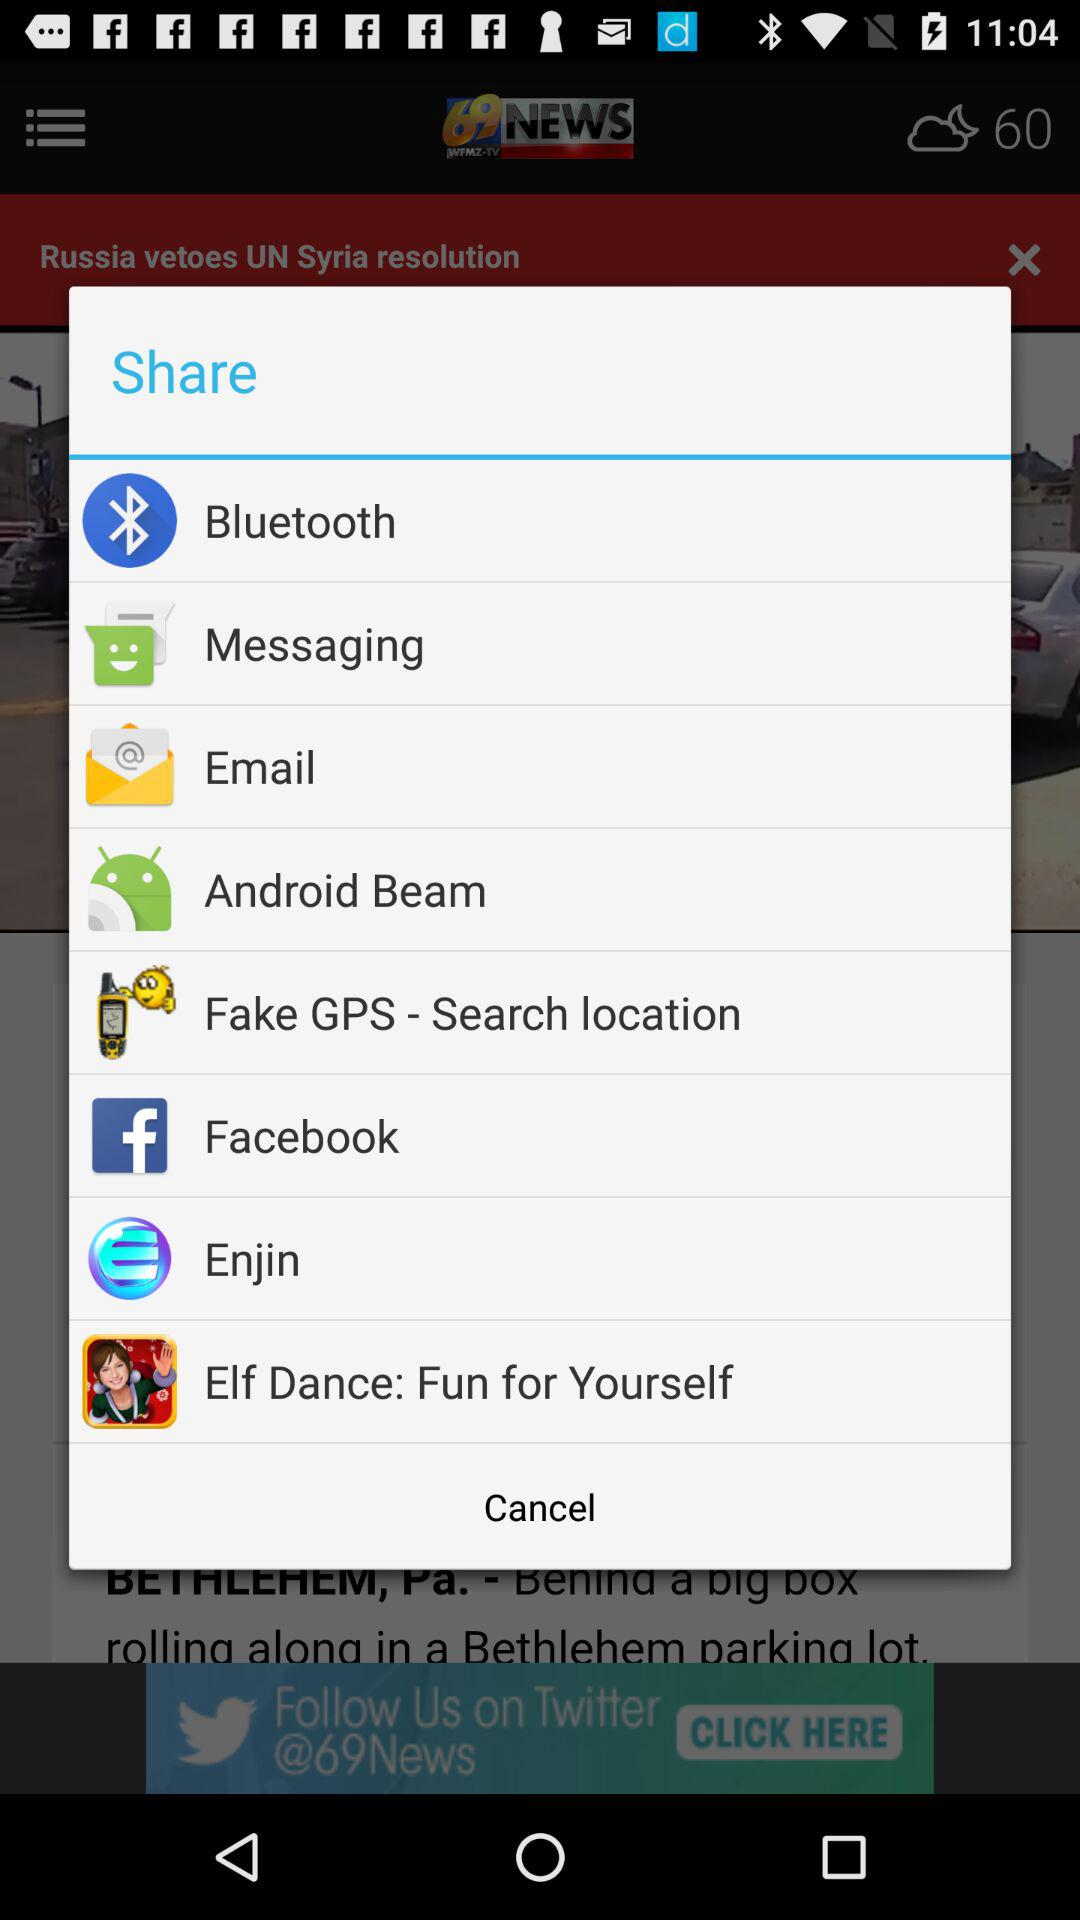What are the options to share? The options are "Bluetooth", "Messaging", "Email", "Android Beam", "Fake GPS-Search location", "Facebook", "Enjin", and "Elf Dance: Fun for Yourself". 